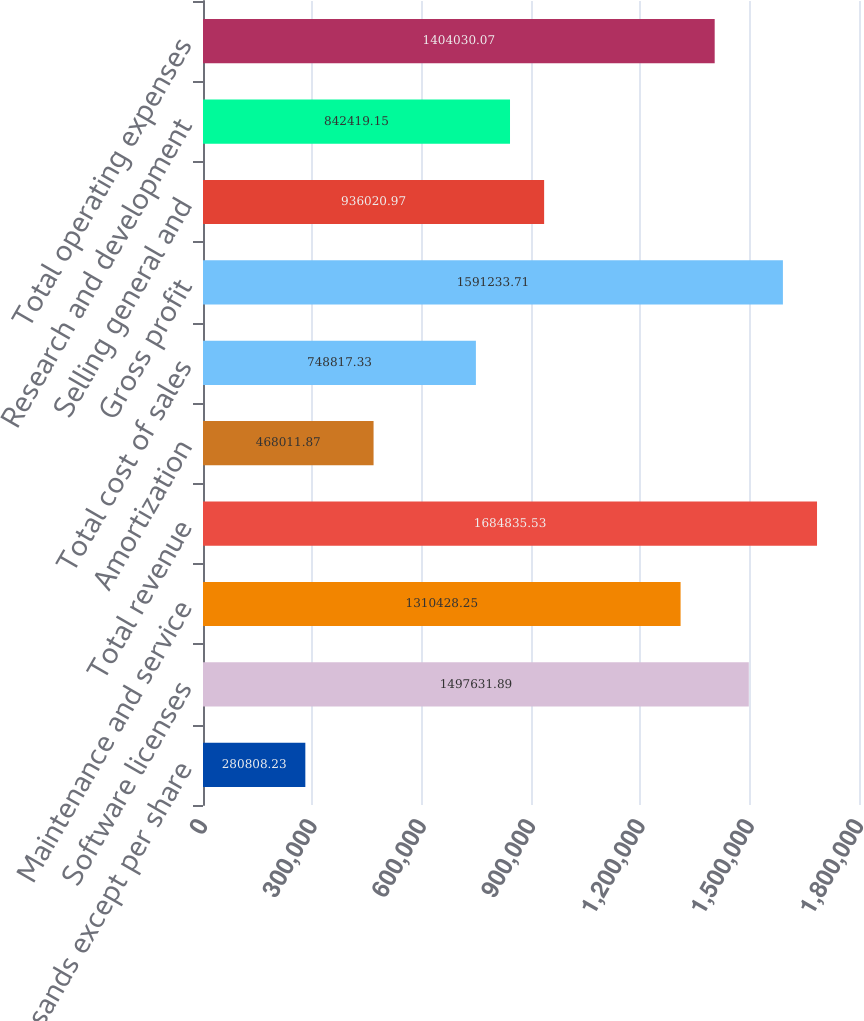Convert chart to OTSL. <chart><loc_0><loc_0><loc_500><loc_500><bar_chart><fcel>(in thousands except per share<fcel>Software licenses<fcel>Maintenance and service<fcel>Total revenue<fcel>Amortization<fcel>Total cost of sales<fcel>Gross profit<fcel>Selling general and<fcel>Research and development<fcel>Total operating expenses<nl><fcel>280808<fcel>1.49763e+06<fcel>1.31043e+06<fcel>1.68484e+06<fcel>468012<fcel>748817<fcel>1.59123e+06<fcel>936021<fcel>842419<fcel>1.40403e+06<nl></chart> 